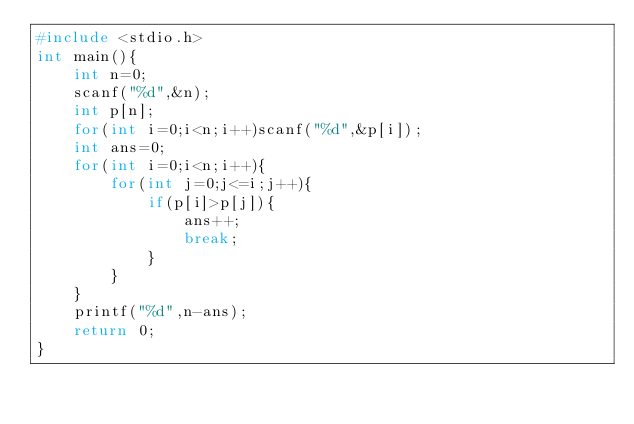Convert code to text. <code><loc_0><loc_0><loc_500><loc_500><_C_>#include <stdio.h>
int main(){
    int n=0;
    scanf("%d",&n);
    int p[n];
    for(int i=0;i<n;i++)scanf("%d",&p[i]);
    int ans=0;
    for(int i=0;i<n;i++){
        for(int j=0;j<=i;j++){
            if(p[i]>p[j]){
                ans++;
                break;
            }
        }
    }
    printf("%d",n-ans);
    return 0;
}</code> 